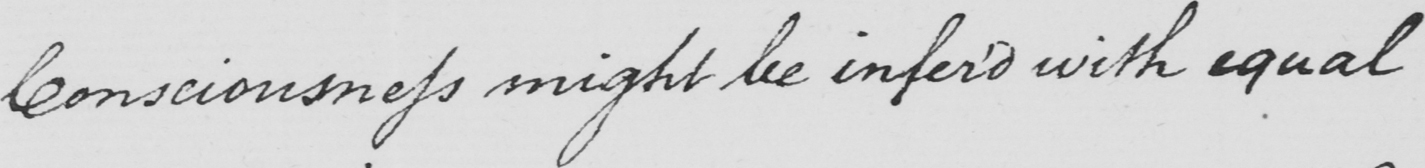Please transcribe the handwritten text in this image. Consciousness might by infer'd with equal 